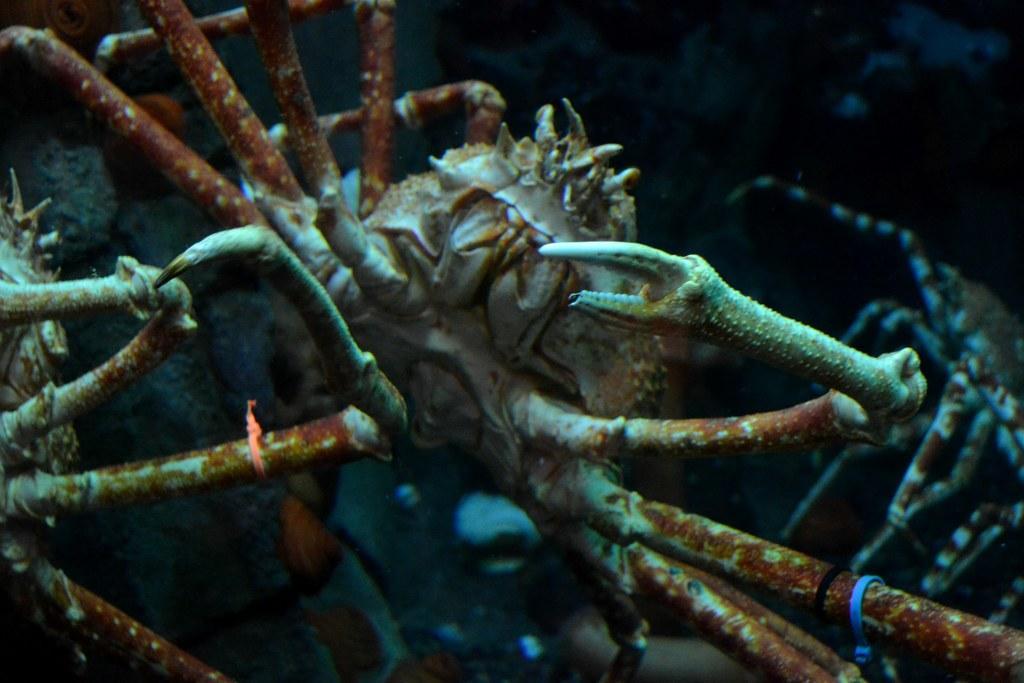Please provide a concise description of this image. In this picture we can see king crabs. In the background of the image it is dark. 